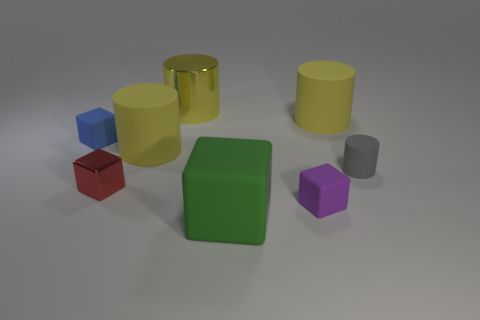There is a purple matte object on the right side of the small blue block that is on the left side of the small matte block in front of the small red thing; what is its size?
Offer a very short reply. Small. What is the size of the cube that is both to the left of the tiny purple block and on the right side of the small red metallic thing?
Your response must be concise. Large. What is the shape of the big yellow matte object that is in front of the big cylinder on the right side of the small purple matte object?
Ensure brevity in your answer.  Cylinder. Is there anything else that has the same color as the big metal object?
Give a very brief answer. Yes. What is the shape of the metal thing behind the tiny gray matte cylinder?
Give a very brief answer. Cylinder. There is a object that is to the right of the large rubber block and behind the gray object; what shape is it?
Make the answer very short. Cylinder. What number of yellow objects are big matte things or shiny cylinders?
Your response must be concise. 3. Do the shiny thing behind the tiny blue object and the tiny metallic block have the same color?
Offer a very short reply. No. How big is the yellow matte object that is left of the tiny cube that is right of the big shiny cylinder?
Ensure brevity in your answer.  Large. What material is the purple cube that is the same size as the gray matte cylinder?
Offer a very short reply. Rubber. 